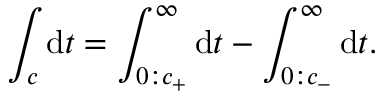Convert formula to latex. <formula><loc_0><loc_0><loc_500><loc_500>\int _ { c } d t = \int _ { 0 \colon c _ { + } } ^ { \infty } d t - \int _ { 0 \colon c _ { - } } ^ { \infty } d t .</formula> 